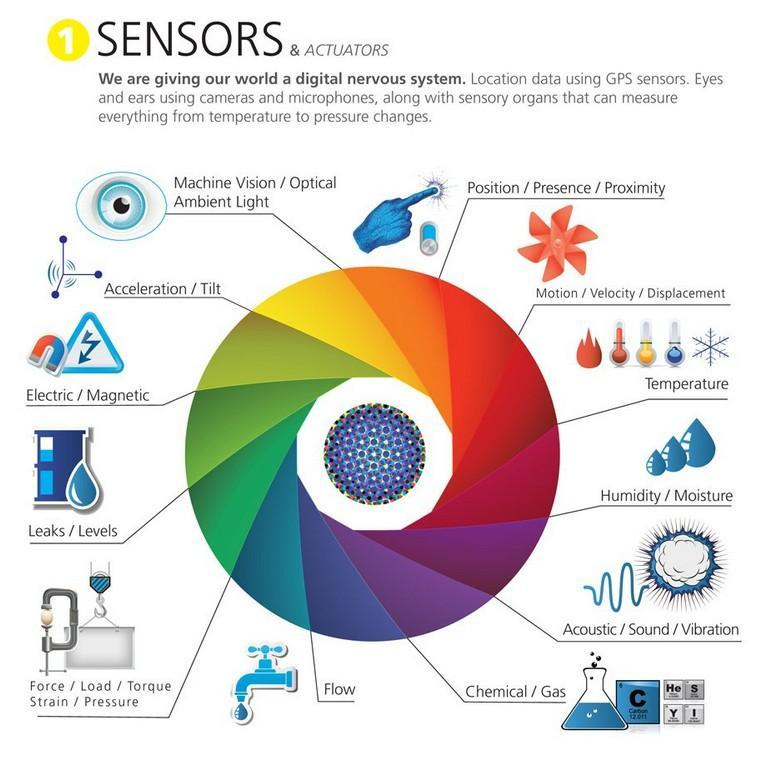Which are the sensors mapped in the yellow region?
Answer the question with a short phrase. Acceleration / Tilt, Machine Vision / Optical Ambient Light 